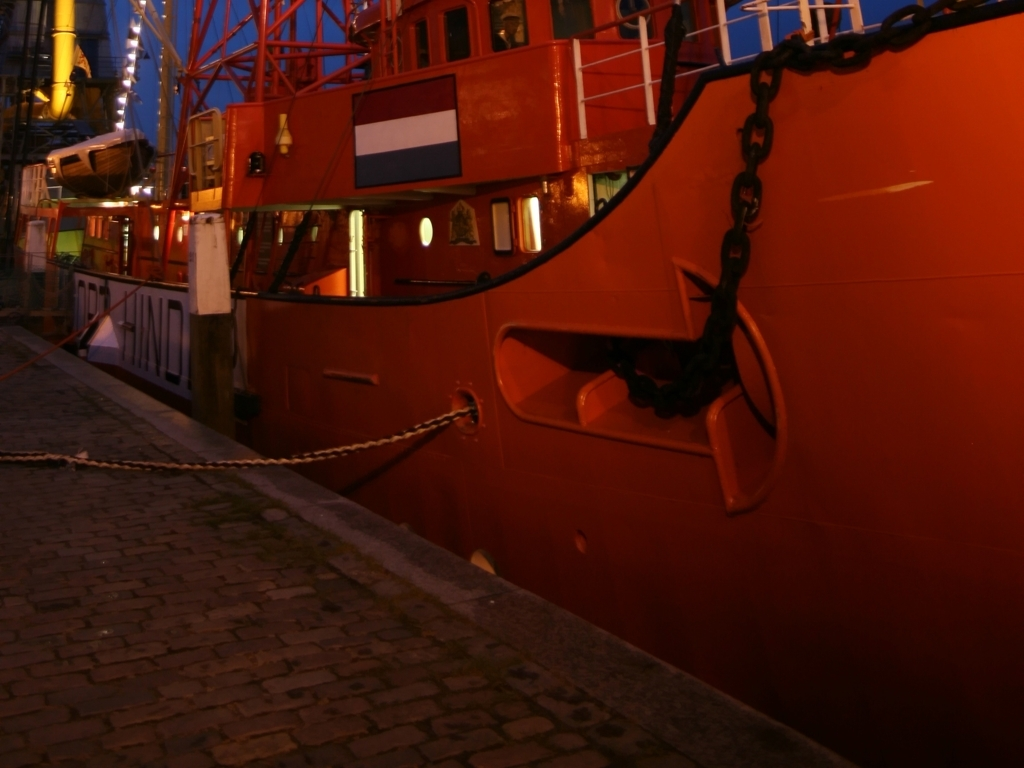How would you describe the subject in this image?
A. Invisible
B. Clear
C. Blurry
D. Indistinct
Answer with the option's letter from the given choices directly. The most accurate description for the subject in the image would be 'C. Blurry', as the image shows a scene with elements that lack sharpness or fine detail, particularly noticeable in the background. The lighting conditions seem to be low, and the photograph may have a slow shutter speed or focus issues that cause the blurriness. 